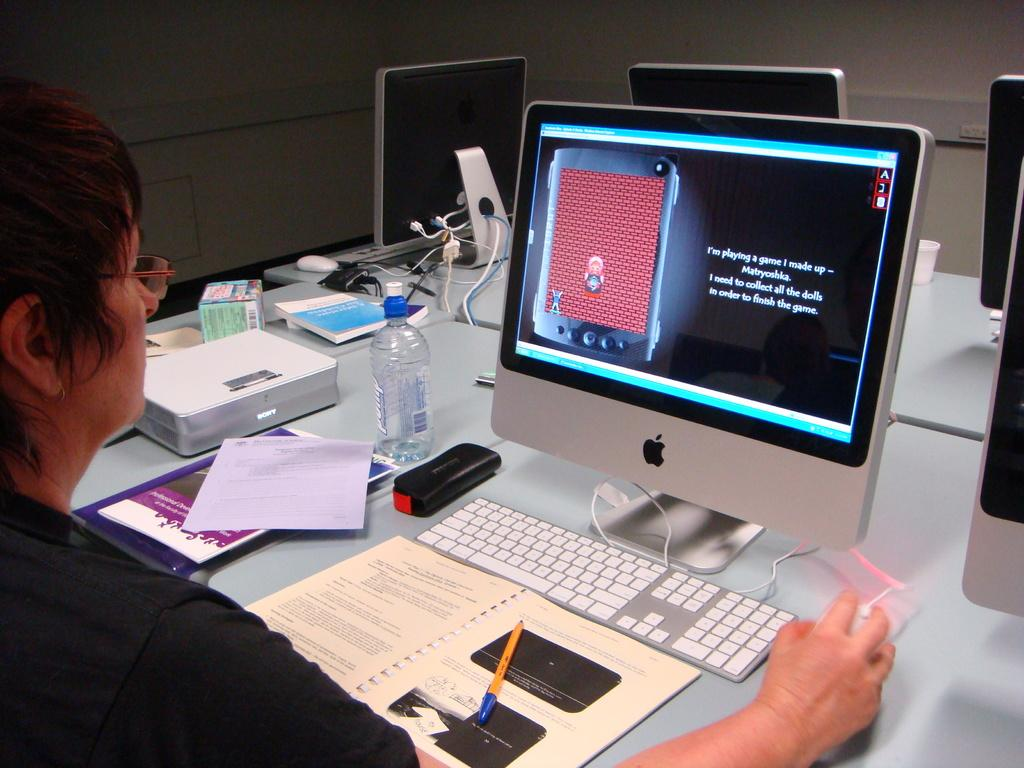<image>
Provide a brief description of the given image. A woman is playing a game on a computer and she needs to collect all the dolls to finish the game. 